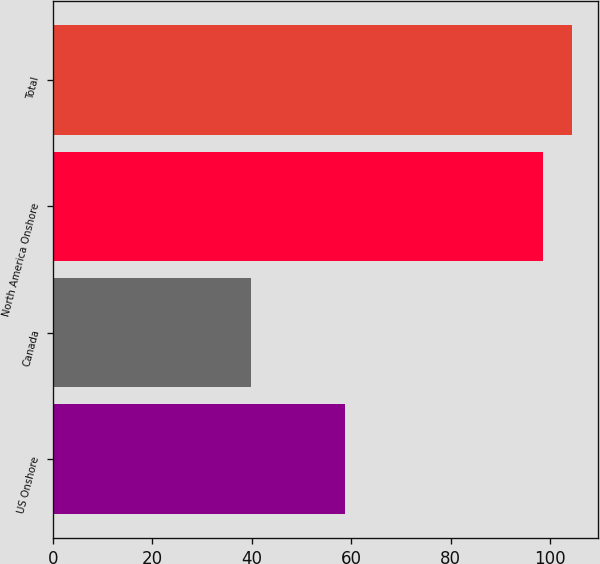Convert chart. <chart><loc_0><loc_0><loc_500><loc_500><bar_chart><fcel>US Onshore<fcel>Canada<fcel>North America Onshore<fcel>Total<nl><fcel>58.7<fcel>39.8<fcel>98.5<fcel>104.37<nl></chart> 